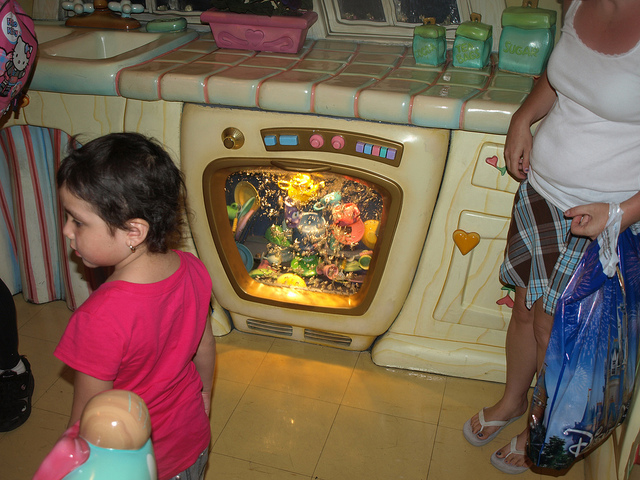Can you tell me more about the setting of this image? Certainly! The image shows an indoor setting with a whimsical design, possibly a part of an amusement park or a themed play area. The oven with the aquarium scene suggests a child-friendly environment focused on imaginative play. 